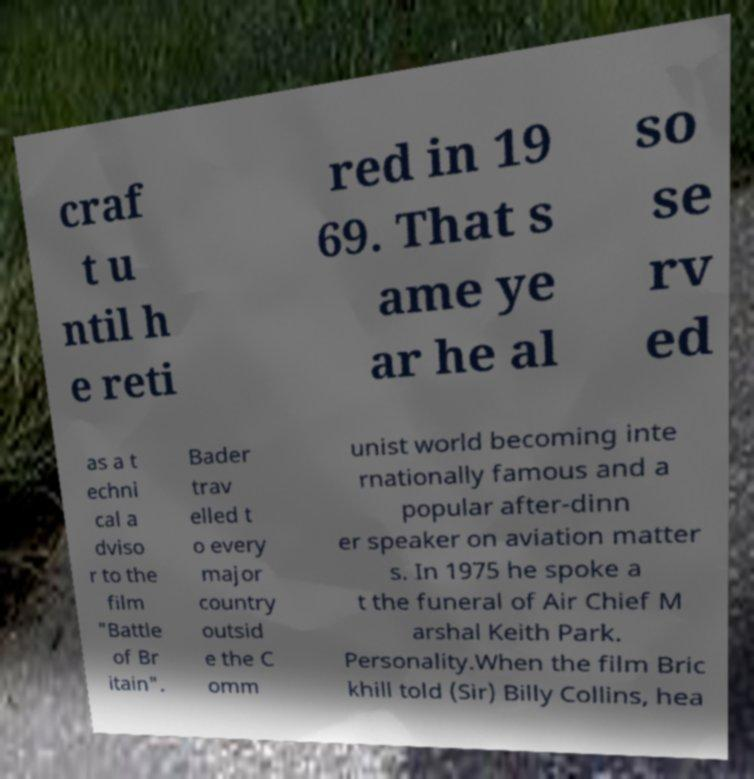Can you read and provide the text displayed in the image?This photo seems to have some interesting text. Can you extract and type it out for me? craf t u ntil h e reti red in 19 69. That s ame ye ar he al so se rv ed as a t echni cal a dviso r to the film "Battle of Br itain". Bader trav elled t o every major country outsid e the C omm unist world becoming inte rnationally famous and a popular after-dinn er speaker on aviation matter s. In 1975 he spoke a t the funeral of Air Chief M arshal Keith Park. Personality.When the film Bric khill told (Sir) Billy Collins, hea 